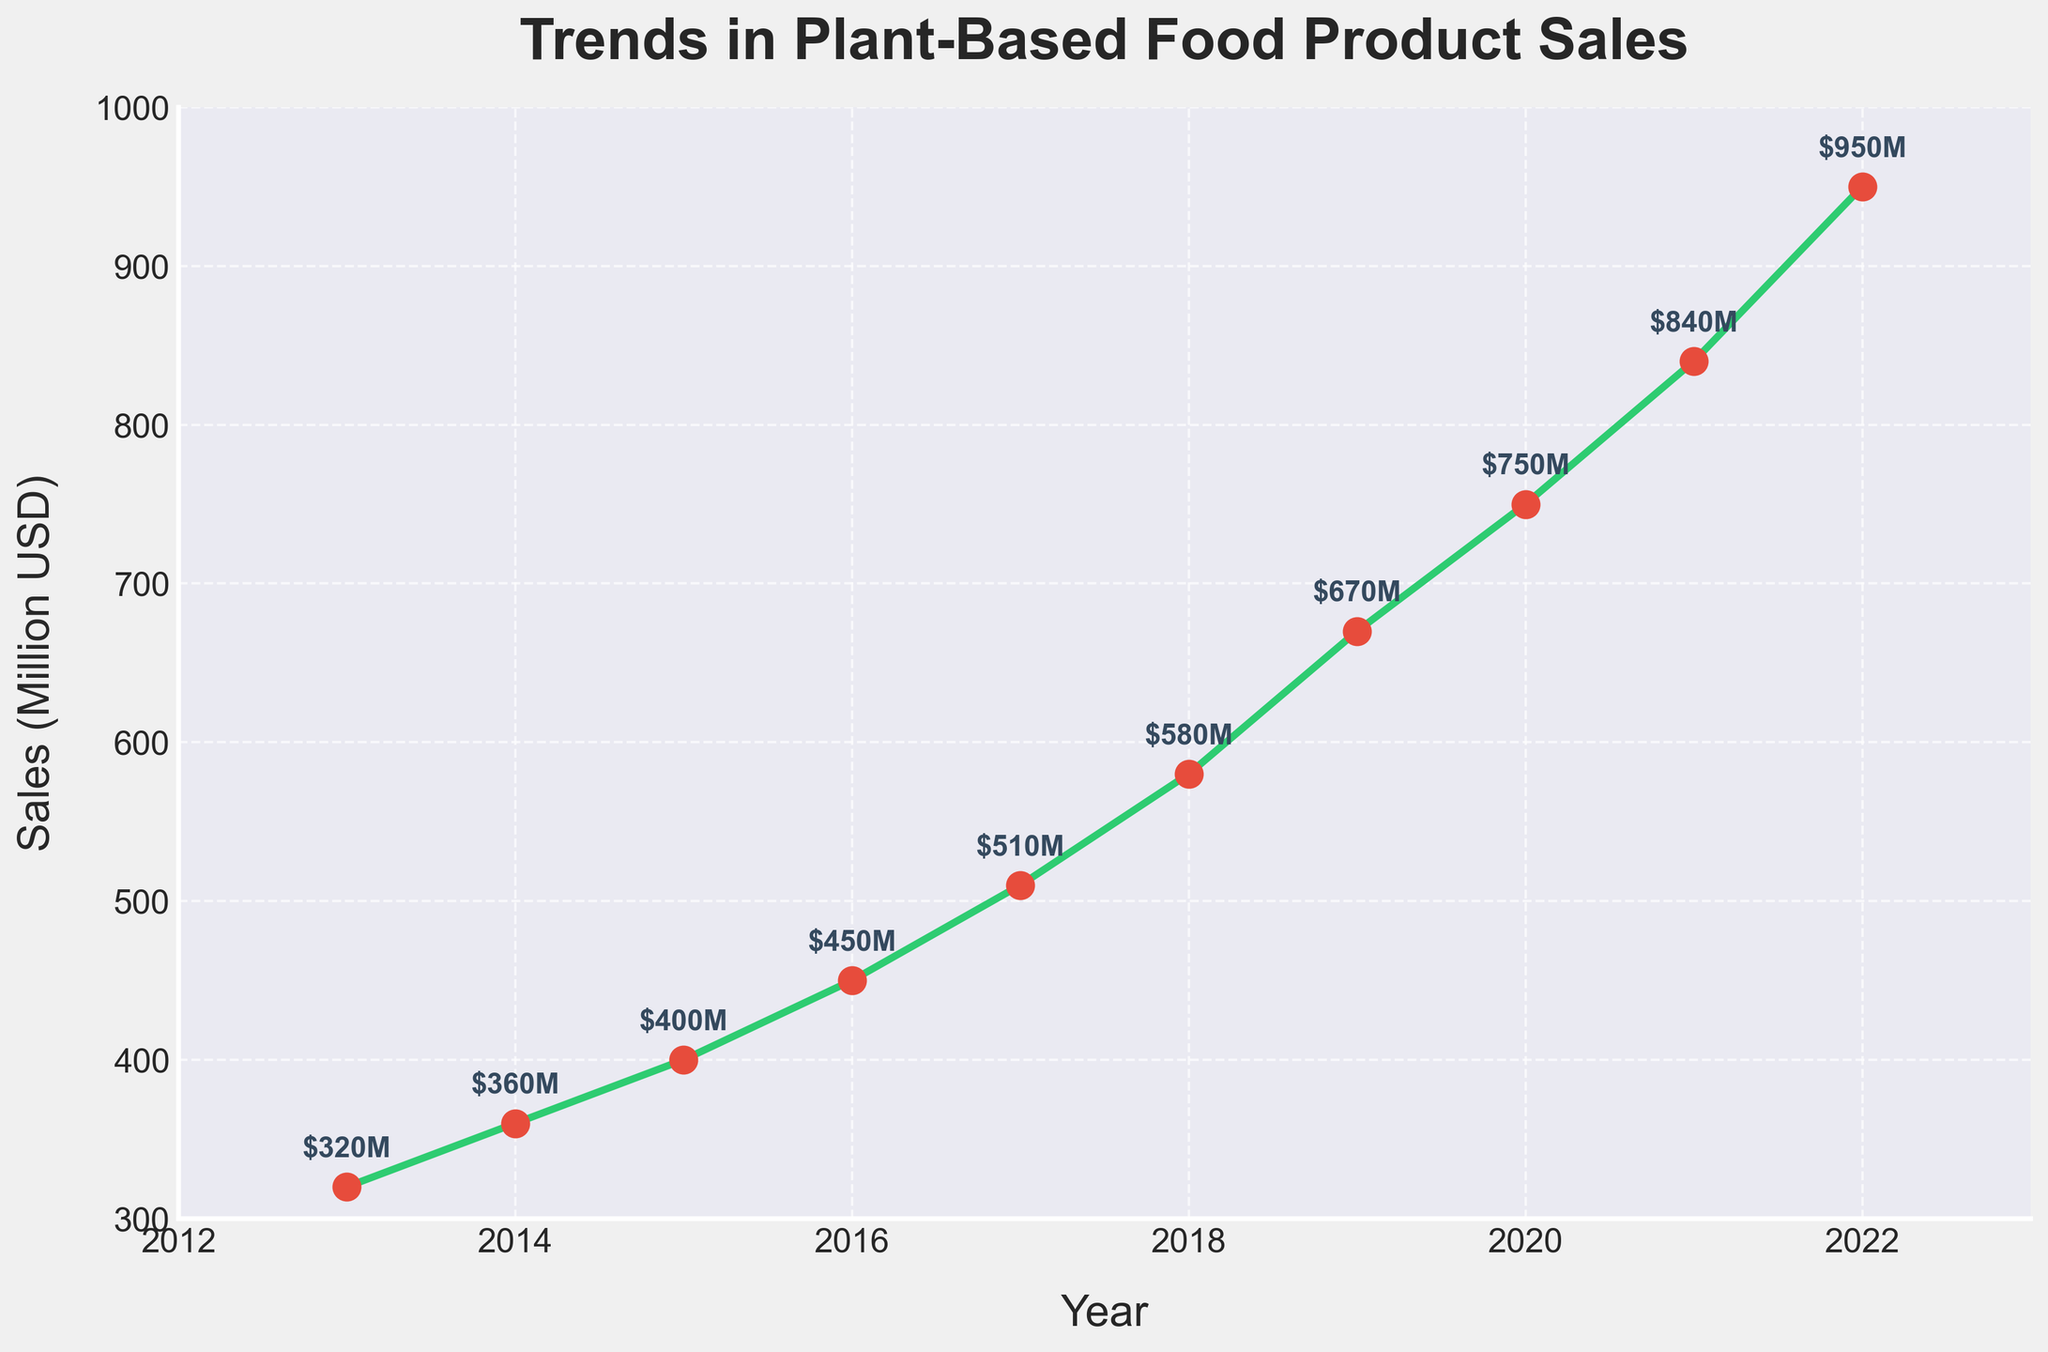what is the title of the plot? The title is displayed at the top of the plot in bold font.
Answer: Trends in Plant-Based Food Product Sales How many years are represented in the plot? There are data points for each year, which can be counted.
Answer: 10 What is the plant-based food sales value for the year 2020? Look for the 2020 annotation on the plot and the associated sales value.
Answer: 750 million USD How much did plant-based food sales increase from 2016 to 2017? Subtract the 2016 sales value from the 2017 sales value (510 - 450).
Answer: 60 million USD What is the difference in sales between the year with the highest and the lowest sales? Highest sales (2022) minus lowest sales (2013) (950 - 320).
Answer: 630 million USD In which year did plant-based food sales reach 580 million USD? Locate the annotation $580M on the plot and identify the associated year.
Answer: 2018 How does the annual sales growth rate change from 2017 to 2018 and from 2018 to 2019 compare? Calculate the growth for both periods (2018-2017 and 2019-2018), compare them (580-510 and 670-580).
Answer: 7 million more in 2018-2019 Which year had a higher plant-based food sales value, 2015 or 2016? Compare the sales values for both years (400 for 2015 and 450 for 2016).
Answer: 2016 What is the average annual increase in plant-based food sales over the decade? Calculate the annual differences, sum them, and divide by the number of intervals (630 / 9).
Answer: 70 million USD per year Is there any year where plant-based food sales decreased compared to the previous year? Check the plot for any downward trend between consecutive years (not present in this data).
Answer: No 